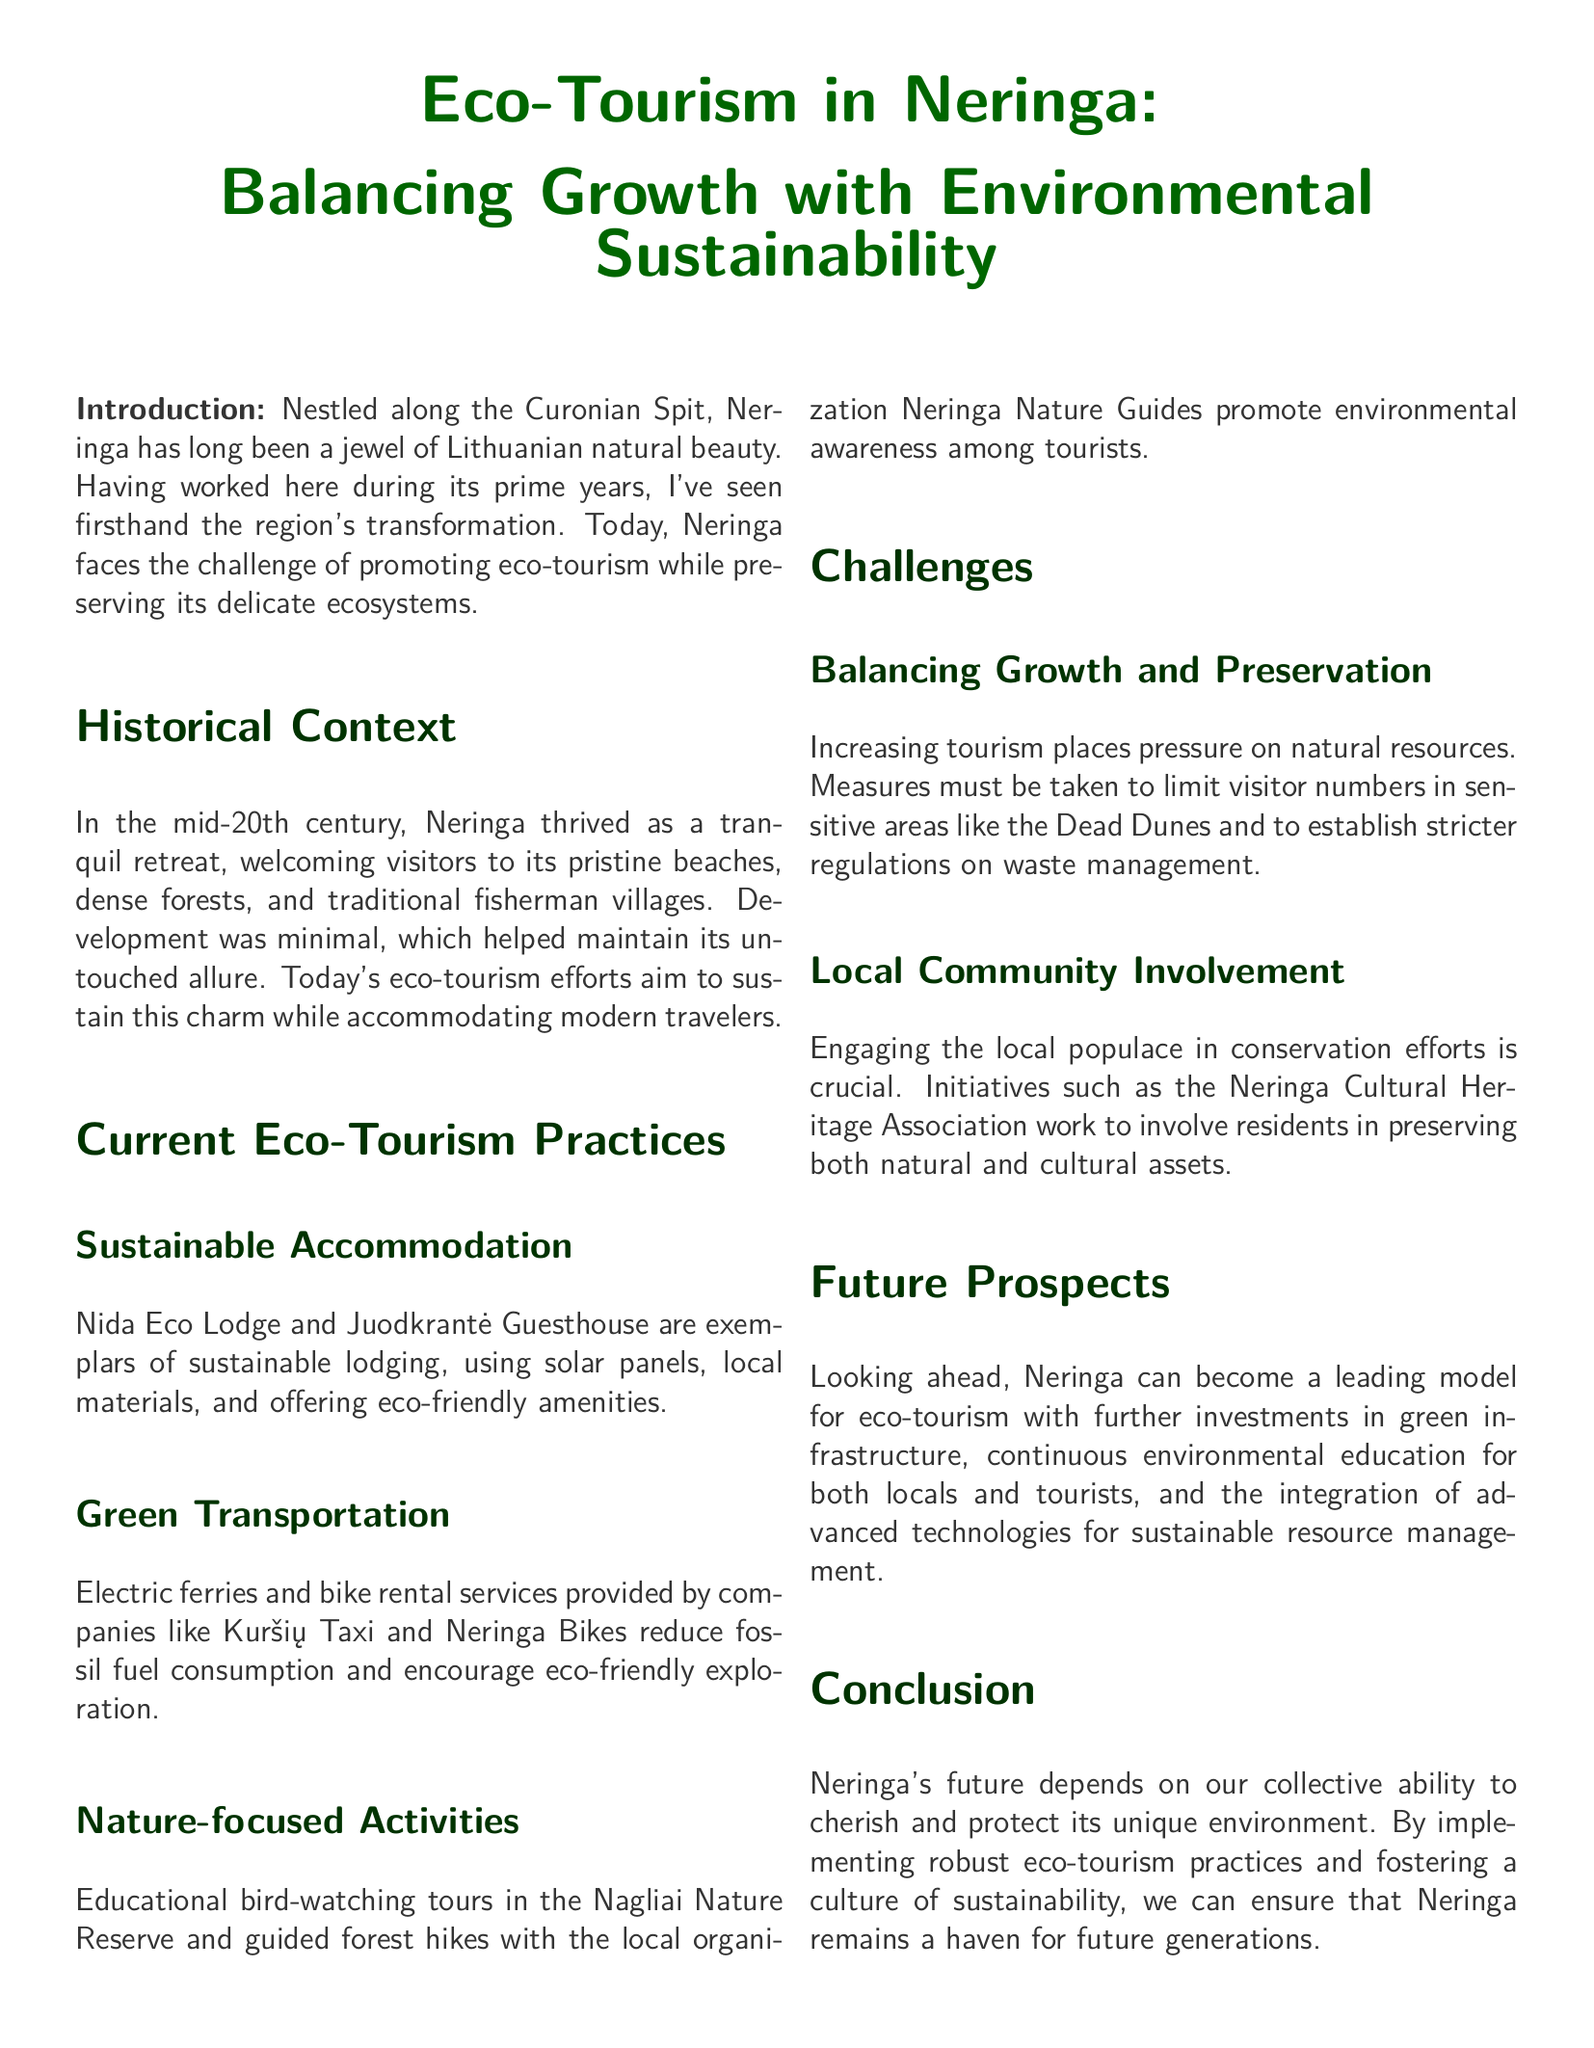What is the title of the whitepaper? The title of the whitepaper is prominently displayed at the beginning of the document.
Answer: Eco-Tourism in Neringa: Balancing Growth with Environmental Sustainability What is a key challenge faced by Neringa? The document lists challenges under relevant sections, particularly focusing on growth pressures.
Answer: Balancing Growth and Preservation What are two examples of sustainable accommodation mentioned? The document provides examples of eco-friendly lodging options in a specific section.
Answer: Nida Eco Lodge and Juodkrantė Guesthouse Which organization promotes nature-focused activities? The document identifies a specific organization involved in environmental activities.
Answer: Neringa Nature Guides What key aspect is crucial for local community involvement? The document discusses the importance of community in conservation efforts.
Answer: Engaging the local populace What future prospects are suggested for Neringa? The conclusion sections of the document emphasize possible directions for eco-tourism development.
Answer: Green infrastructure How do electric ferries contribute to eco-tourism? The document explains transportation methods that support sustainable tourism efforts.
Answer: Reduce fossil fuel consumption What natural area requires visitor number limits? Specific sensitive areas are mentioned in the context of tourism management challenges.
Answer: Dead Dunes 